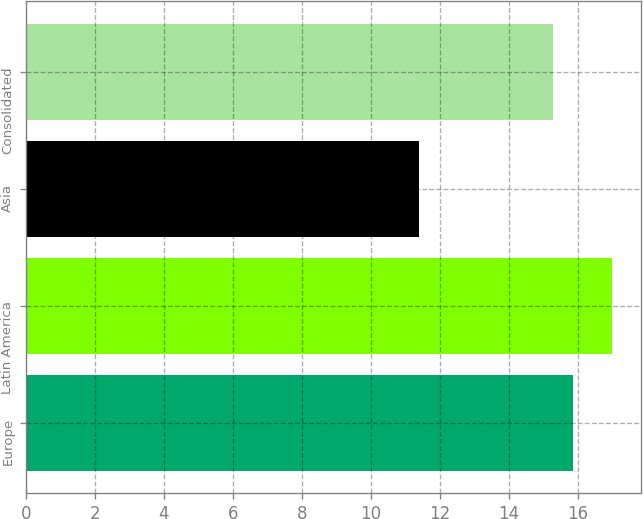Convert chart to OTSL. <chart><loc_0><loc_0><loc_500><loc_500><bar_chart><fcel>Europe<fcel>Latin America<fcel>Asia<fcel>Consolidated<nl><fcel>15.86<fcel>17<fcel>11.4<fcel>15.3<nl></chart> 